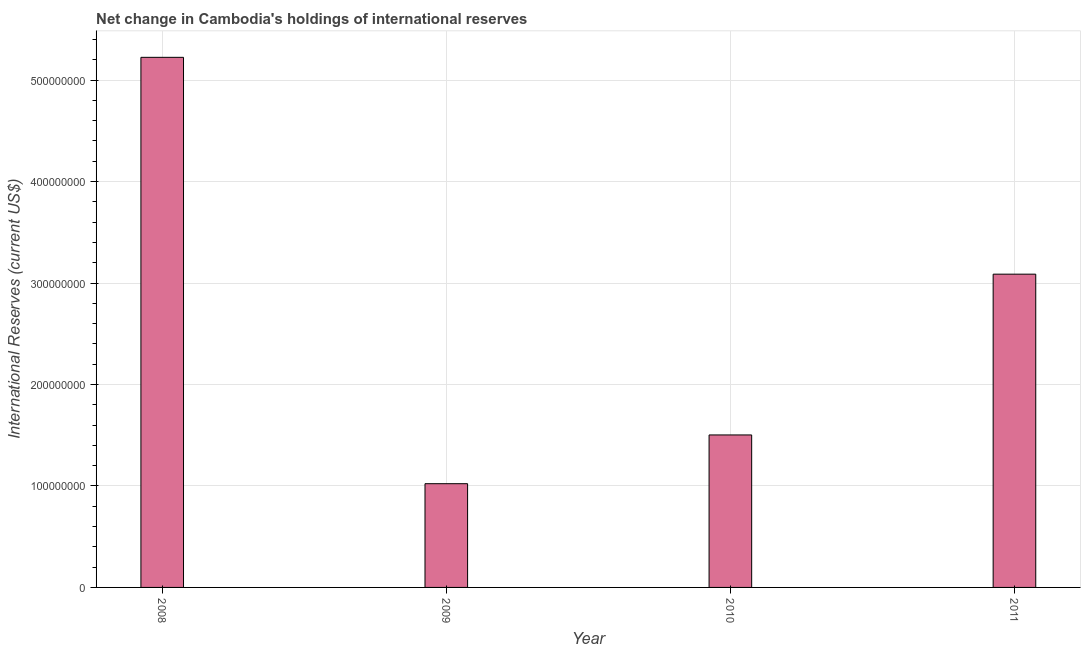Does the graph contain any zero values?
Your answer should be very brief. No. What is the title of the graph?
Offer a terse response. Net change in Cambodia's holdings of international reserves. What is the label or title of the X-axis?
Make the answer very short. Year. What is the label or title of the Y-axis?
Provide a short and direct response. International Reserves (current US$). What is the reserves and related items in 2011?
Provide a succinct answer. 3.09e+08. Across all years, what is the maximum reserves and related items?
Your answer should be very brief. 5.22e+08. Across all years, what is the minimum reserves and related items?
Keep it short and to the point. 1.02e+08. In which year was the reserves and related items maximum?
Offer a very short reply. 2008. In which year was the reserves and related items minimum?
Your response must be concise. 2009. What is the sum of the reserves and related items?
Your answer should be compact. 1.08e+09. What is the difference between the reserves and related items in 2008 and 2011?
Your answer should be compact. 2.14e+08. What is the average reserves and related items per year?
Give a very brief answer. 2.71e+08. What is the median reserves and related items?
Give a very brief answer. 2.30e+08. What is the ratio of the reserves and related items in 2009 to that in 2011?
Your answer should be very brief. 0.33. What is the difference between the highest and the second highest reserves and related items?
Give a very brief answer. 2.14e+08. What is the difference between the highest and the lowest reserves and related items?
Your answer should be very brief. 4.20e+08. How many bars are there?
Provide a succinct answer. 4. Are the values on the major ticks of Y-axis written in scientific E-notation?
Your response must be concise. No. What is the International Reserves (current US$) in 2008?
Your answer should be very brief. 5.22e+08. What is the International Reserves (current US$) in 2009?
Give a very brief answer. 1.02e+08. What is the International Reserves (current US$) of 2010?
Your answer should be compact. 1.50e+08. What is the International Reserves (current US$) of 2011?
Keep it short and to the point. 3.09e+08. What is the difference between the International Reserves (current US$) in 2008 and 2009?
Your answer should be very brief. 4.20e+08. What is the difference between the International Reserves (current US$) in 2008 and 2010?
Offer a terse response. 3.72e+08. What is the difference between the International Reserves (current US$) in 2008 and 2011?
Provide a succinct answer. 2.14e+08. What is the difference between the International Reserves (current US$) in 2009 and 2010?
Your answer should be compact. -4.80e+07. What is the difference between the International Reserves (current US$) in 2009 and 2011?
Provide a succinct answer. -2.06e+08. What is the difference between the International Reserves (current US$) in 2010 and 2011?
Provide a succinct answer. -1.58e+08. What is the ratio of the International Reserves (current US$) in 2008 to that in 2009?
Give a very brief answer. 5.11. What is the ratio of the International Reserves (current US$) in 2008 to that in 2010?
Offer a terse response. 3.48. What is the ratio of the International Reserves (current US$) in 2008 to that in 2011?
Give a very brief answer. 1.69. What is the ratio of the International Reserves (current US$) in 2009 to that in 2010?
Your answer should be very brief. 0.68. What is the ratio of the International Reserves (current US$) in 2009 to that in 2011?
Offer a terse response. 0.33. What is the ratio of the International Reserves (current US$) in 2010 to that in 2011?
Ensure brevity in your answer.  0.49. 